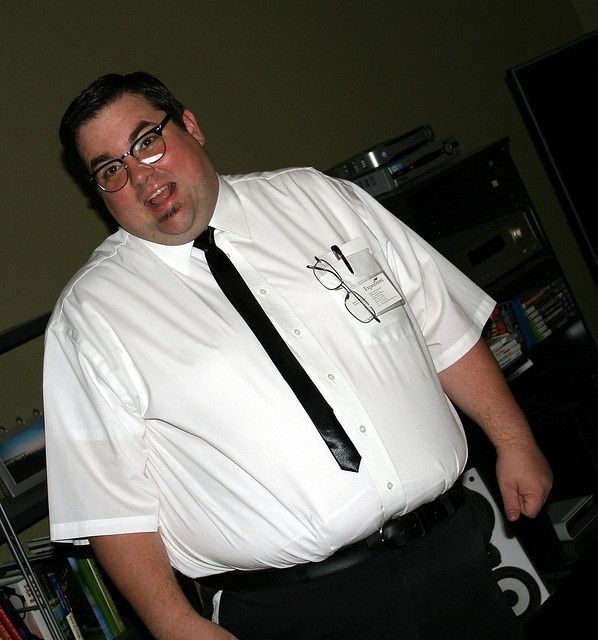Describe the objects in this image and their specific colors. I can see people in black, lightgray, darkgray, and brown tones, tie in black, gray, darkgray, and purple tones, book in black, blue, darkblue, and gray tones, book in black and gray tones, and book in black, darkgreen, and gray tones in this image. 